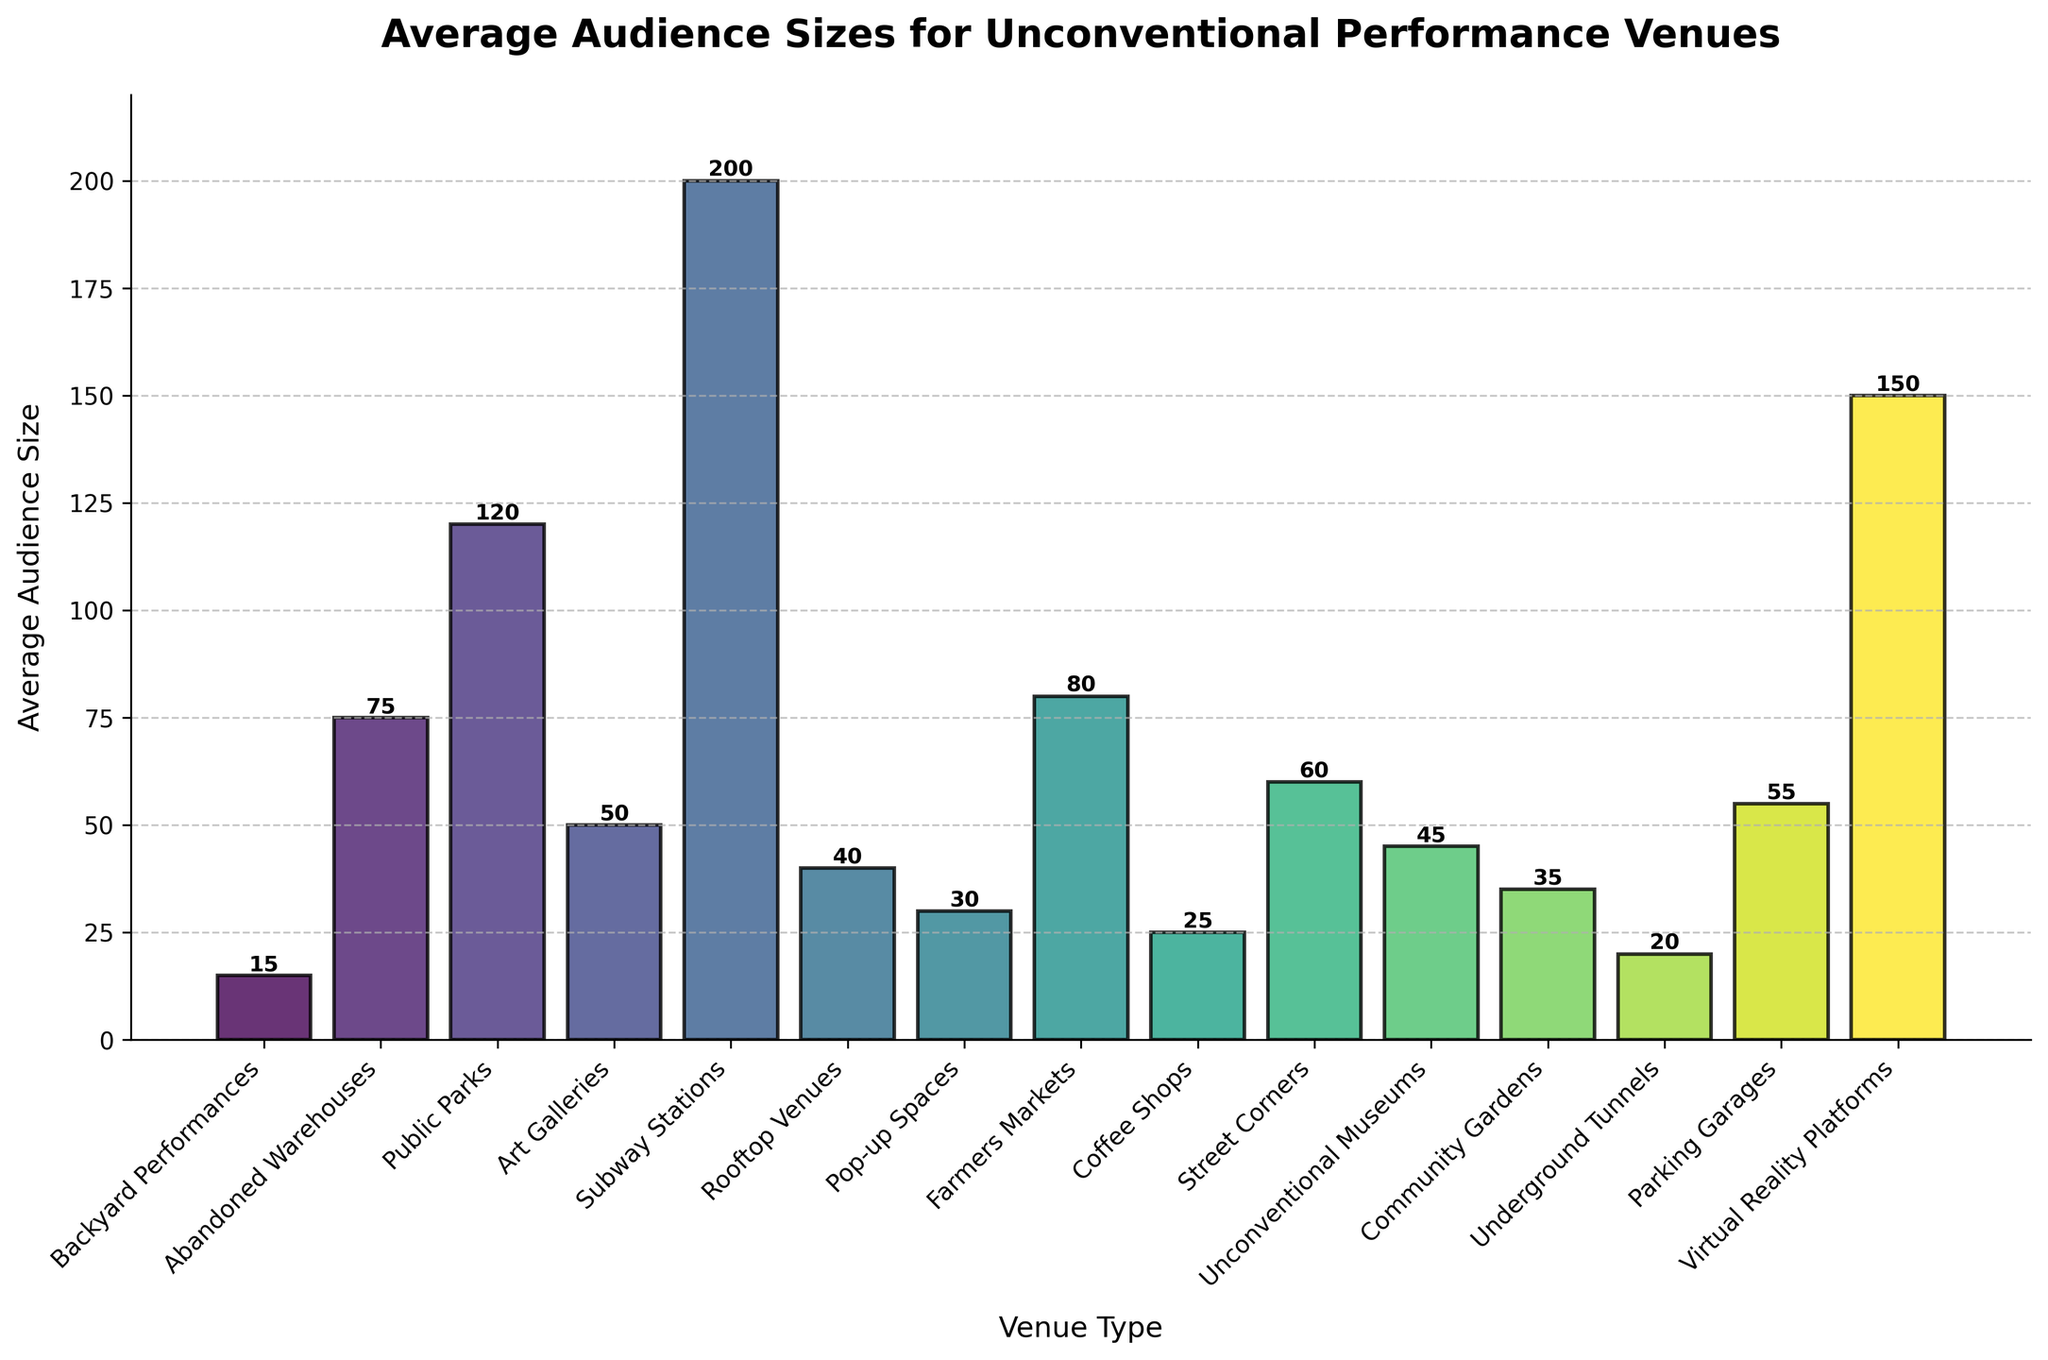Which venue type has the highest average audience size? Look at the bar chart and identify the tallest bar. The tallest bar represents the Subway Stations with an average audience size of 200.
Answer: Subway Stations What is the difference in average audience size between Public Parks and Art Galleries? Subtract the average audience size of Art Galleries from that of Public Parks: 120 - 50 = 70.
Answer: 70 Which two venue types have the closest average audience sizes? Compare the average audience sizes and find the two closest values. Community Gardens (35) and Coffee Shops (25) have a difference of 10, Rooftop Venues (40) and Unconventional Museums (45) have a difference of 5. Therefore, Rooftop Venues and Unconventional Museums have the closest sizes.
Answer: Rooftop Venues and Unconventional Museums What is the combined average audience size for Backyard Performances, Virtual Reality Platforms, and Farmers Markets? Sum the average audience sizes of these three venues: 15 (Backyard Performances) + 150 (Virtual Reality Platforms) + 80 (Farmers Markets) = 245.
Answer: 245 Which venue type has a larger audience, Street Corners or Parking Garages? Compare the heights of the bars representing Street Corners and Parking Garages. Parking Garages have an average audience size of 55, while Street Corners have 60.
Answer: Street Corners What is the average size of audiences for venues with less than 50 average audience size? Identify venues with less than 50 average audience sizes: Backyard Performances (15), Coffee Shops (25), Underground Tunnels (20), Pop-up Spaces (30), Community Gardens (35), Unconventional Museums (45), Rooftop Venues (40). Sum their audience sizes and divide by the number of such venues: (15 + 25 + 20 + 30 + 35 + 45 + 40) / 7 = 210 / 7 = 30.
Answer: 30 Are there more venues with average audience sizes above 100 or below 100? Count the number of venues above and below 100: Above 100: Subway Stations (200), Public Parks (120), Virtual Reality Platforms (150) = 3 venues. Below 100: Remaining 12 venues.
Answer: Below 100 What is the relationship between Abandoned Warehouses and Farmers Markets in terms of audience size? Compare the height of the bars for Abandoned Warehouses and Farmers Markets. The average audience size for Abandoned Warehouses is 75, which is smaller than Farmers Markets with 80.
Answer: Abandoned Warehouses < Farmers Markets 